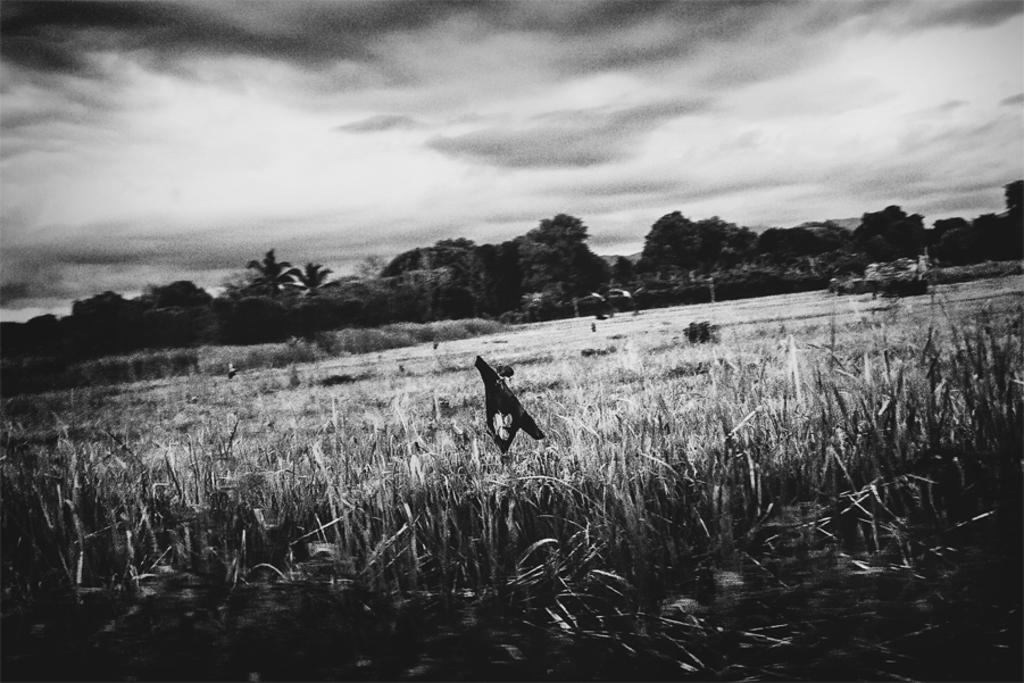What type of vegetation is present in the image? There is grass in the image. What other object can be seen in the image? There is an object that looks like a cloth in the image. What can be seen in the background of the image? There are trees in the background of the image. What is visible at the top of the image? The sky is visible at the top of the image. What type of brass instrument is being played by the turkey in the image? There is no brass instrument or turkey present in the image. What type of voyage is the cloth embarking on in the image? The cloth is not embarking on any voyage in the image; it is simply an object in the scene. 